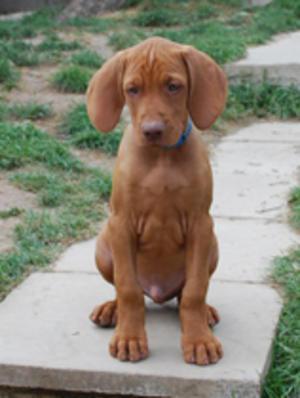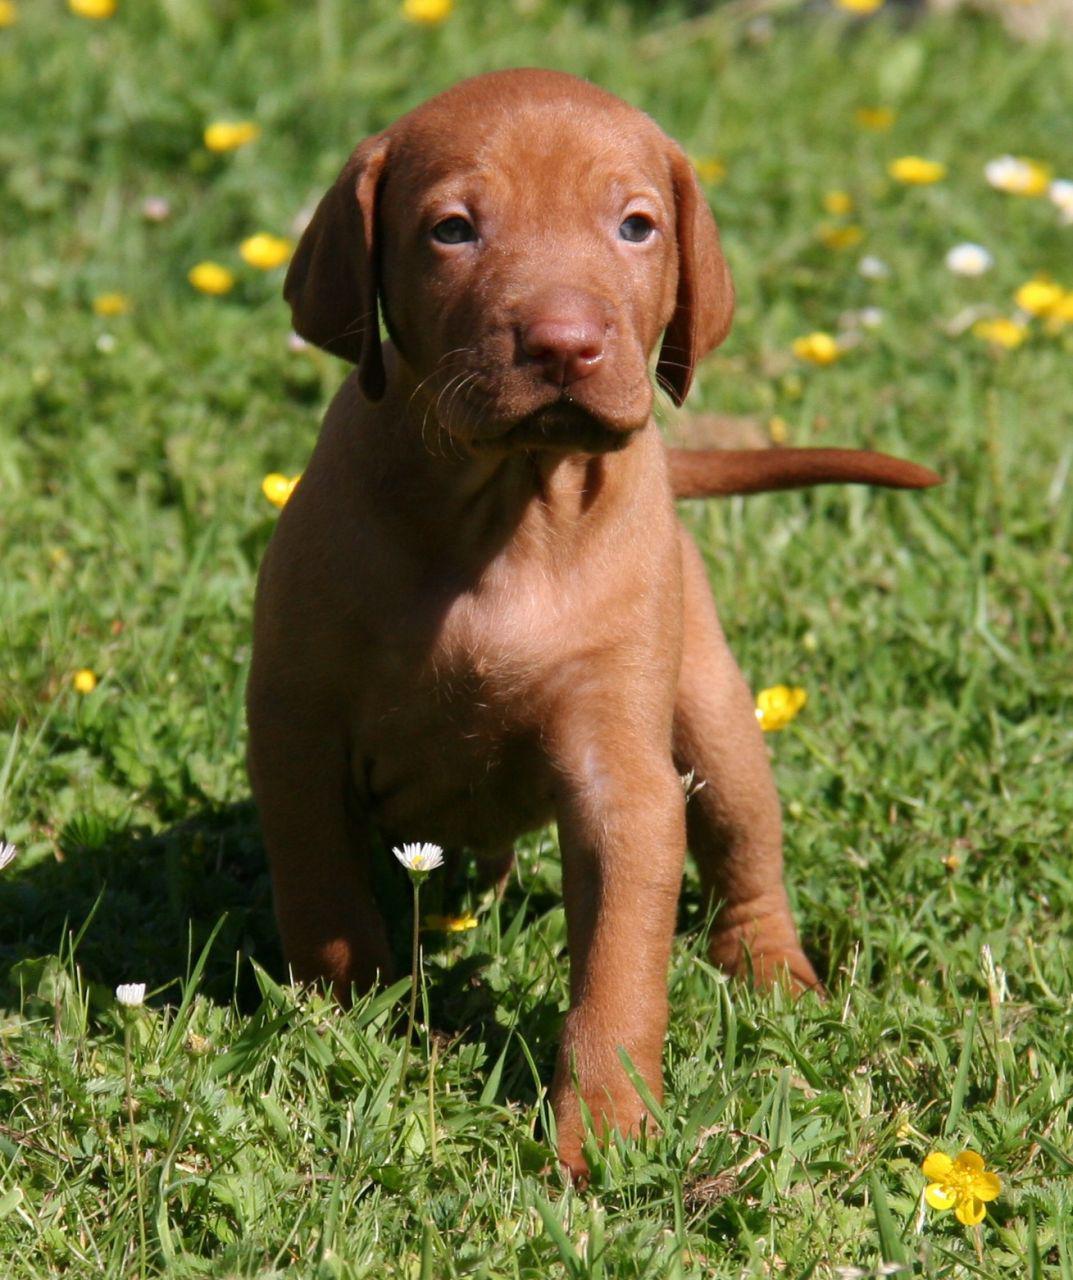The first image is the image on the left, the second image is the image on the right. Examine the images to the left and right. Is the description "A boy and a dog face toward each other in one image, and two dogs are in a natural body of water in the other image." accurate? Answer yes or no. No. The first image is the image on the left, the second image is the image on the right. Analyze the images presented: Is the assertion "The left image contains exactly two dogs." valid? Answer yes or no. No. 